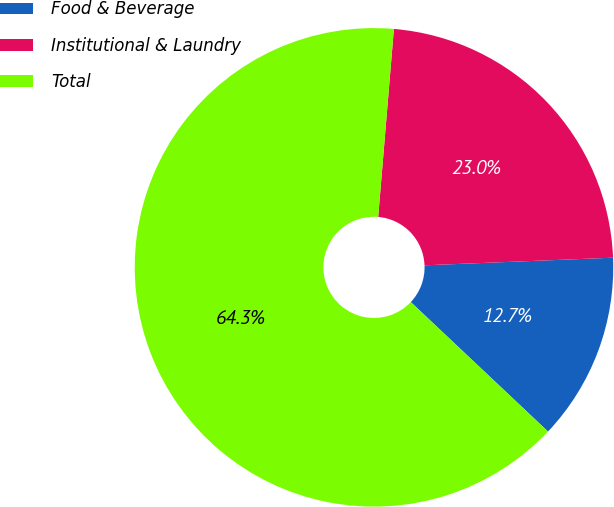Convert chart to OTSL. <chart><loc_0><loc_0><loc_500><loc_500><pie_chart><fcel>Food & Beverage<fcel>Institutional & Laundry<fcel>Total<nl><fcel>12.68%<fcel>23.03%<fcel>64.29%<nl></chart> 